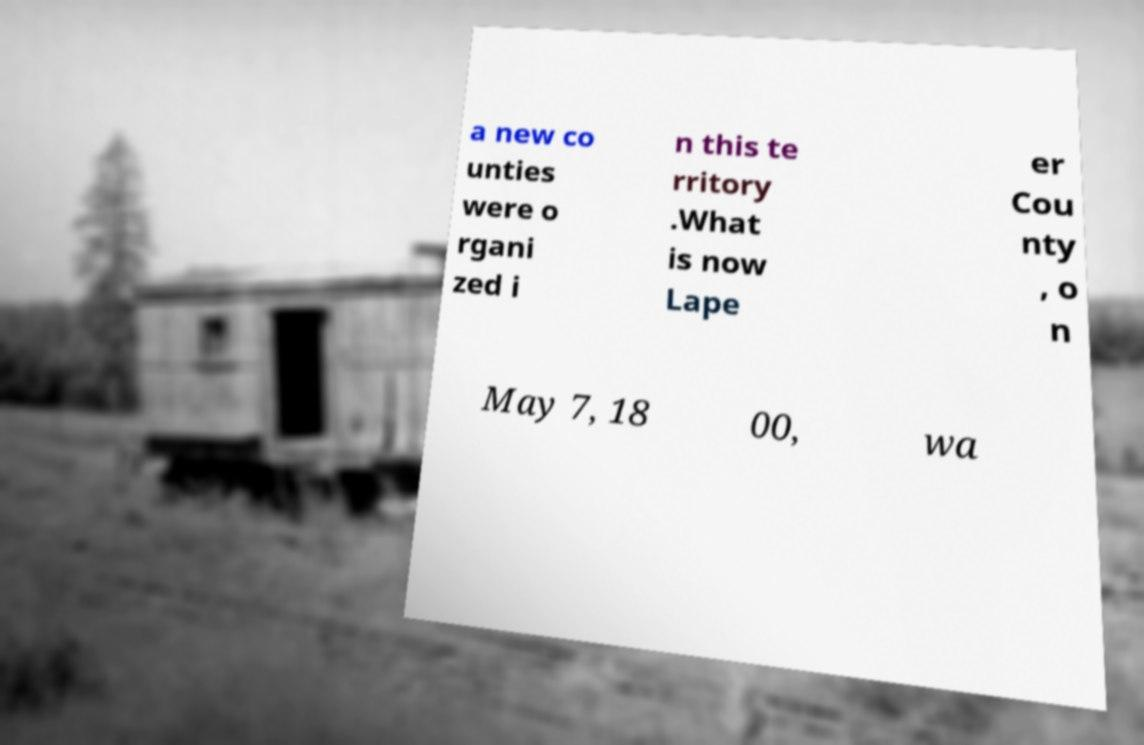Please identify and transcribe the text found in this image. a new co unties were o rgani zed i n this te rritory .What is now Lape er Cou nty , o n May 7, 18 00, wa 